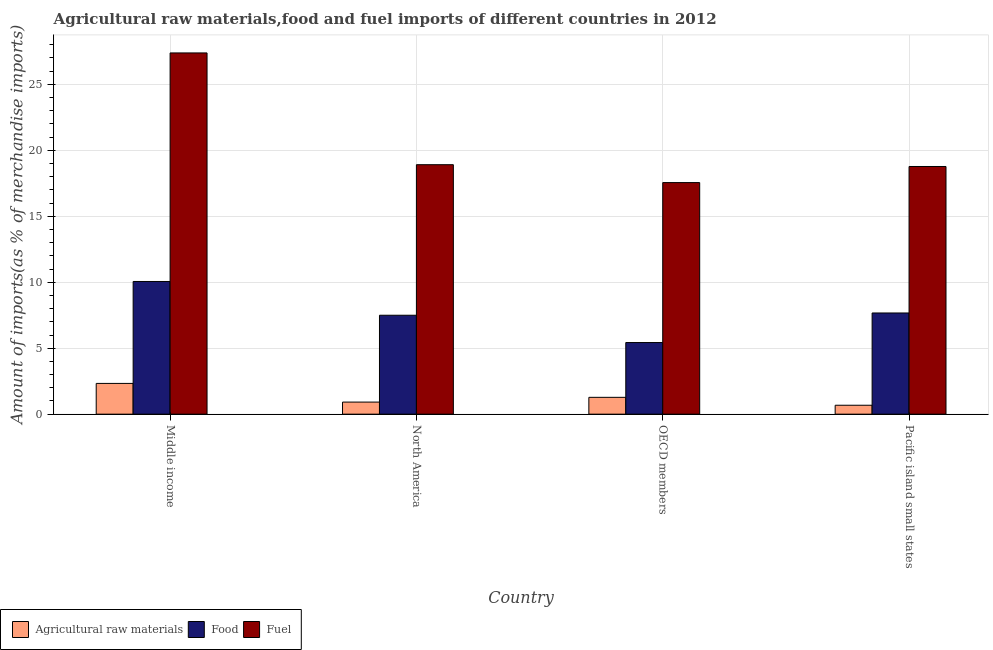How many different coloured bars are there?
Provide a short and direct response. 3. How many groups of bars are there?
Offer a terse response. 4. Are the number of bars per tick equal to the number of legend labels?
Your answer should be compact. Yes. How many bars are there on the 2nd tick from the left?
Offer a very short reply. 3. How many bars are there on the 2nd tick from the right?
Make the answer very short. 3. What is the label of the 4th group of bars from the left?
Your answer should be compact. Pacific island small states. In how many cases, is the number of bars for a given country not equal to the number of legend labels?
Ensure brevity in your answer.  0. What is the percentage of raw materials imports in Pacific island small states?
Ensure brevity in your answer.  0.68. Across all countries, what is the maximum percentage of fuel imports?
Your answer should be very brief. 27.38. Across all countries, what is the minimum percentage of food imports?
Your response must be concise. 5.43. In which country was the percentage of fuel imports minimum?
Your answer should be compact. OECD members. What is the total percentage of raw materials imports in the graph?
Provide a short and direct response. 5.2. What is the difference between the percentage of food imports in Middle income and that in North America?
Make the answer very short. 2.56. What is the difference between the percentage of raw materials imports in OECD members and the percentage of fuel imports in North America?
Your answer should be compact. -17.63. What is the average percentage of food imports per country?
Keep it short and to the point. 7.66. What is the difference between the percentage of raw materials imports and percentage of food imports in Middle income?
Your answer should be very brief. -7.73. What is the ratio of the percentage of fuel imports in North America to that in OECD members?
Give a very brief answer. 1.08. What is the difference between the highest and the second highest percentage of food imports?
Give a very brief answer. 2.39. What is the difference between the highest and the lowest percentage of fuel imports?
Offer a terse response. 9.83. In how many countries, is the percentage of food imports greater than the average percentage of food imports taken over all countries?
Keep it short and to the point. 2. What does the 2nd bar from the left in Pacific island small states represents?
Provide a succinct answer. Food. What does the 1st bar from the right in North America represents?
Provide a short and direct response. Fuel. Is it the case that in every country, the sum of the percentage of raw materials imports and percentage of food imports is greater than the percentage of fuel imports?
Give a very brief answer. No. How many countries are there in the graph?
Provide a short and direct response. 4. What is the difference between two consecutive major ticks on the Y-axis?
Offer a terse response. 5. Does the graph contain any zero values?
Provide a succinct answer. No. Where does the legend appear in the graph?
Offer a terse response. Bottom left. How many legend labels are there?
Your answer should be compact. 3. How are the legend labels stacked?
Provide a succinct answer. Horizontal. What is the title of the graph?
Ensure brevity in your answer.  Agricultural raw materials,food and fuel imports of different countries in 2012. Does "Ages 20-50" appear as one of the legend labels in the graph?
Offer a terse response. No. What is the label or title of the Y-axis?
Make the answer very short. Amount of imports(as % of merchandise imports). What is the Amount of imports(as % of merchandise imports) of Agricultural raw materials in Middle income?
Provide a short and direct response. 2.33. What is the Amount of imports(as % of merchandise imports) in Food in Middle income?
Keep it short and to the point. 10.06. What is the Amount of imports(as % of merchandise imports) in Fuel in Middle income?
Your answer should be compact. 27.38. What is the Amount of imports(as % of merchandise imports) in Agricultural raw materials in North America?
Offer a terse response. 0.92. What is the Amount of imports(as % of merchandise imports) in Food in North America?
Offer a terse response. 7.5. What is the Amount of imports(as % of merchandise imports) in Fuel in North America?
Offer a very short reply. 18.91. What is the Amount of imports(as % of merchandise imports) in Agricultural raw materials in OECD members?
Offer a terse response. 1.28. What is the Amount of imports(as % of merchandise imports) of Food in OECD members?
Give a very brief answer. 5.43. What is the Amount of imports(as % of merchandise imports) in Fuel in OECD members?
Offer a very short reply. 17.55. What is the Amount of imports(as % of merchandise imports) of Agricultural raw materials in Pacific island small states?
Provide a short and direct response. 0.68. What is the Amount of imports(as % of merchandise imports) of Food in Pacific island small states?
Give a very brief answer. 7.67. What is the Amount of imports(as % of merchandise imports) in Fuel in Pacific island small states?
Ensure brevity in your answer.  18.77. Across all countries, what is the maximum Amount of imports(as % of merchandise imports) in Agricultural raw materials?
Provide a succinct answer. 2.33. Across all countries, what is the maximum Amount of imports(as % of merchandise imports) of Food?
Your answer should be compact. 10.06. Across all countries, what is the maximum Amount of imports(as % of merchandise imports) of Fuel?
Offer a terse response. 27.38. Across all countries, what is the minimum Amount of imports(as % of merchandise imports) of Agricultural raw materials?
Your response must be concise. 0.68. Across all countries, what is the minimum Amount of imports(as % of merchandise imports) in Food?
Keep it short and to the point. 5.43. Across all countries, what is the minimum Amount of imports(as % of merchandise imports) in Fuel?
Ensure brevity in your answer.  17.55. What is the total Amount of imports(as % of merchandise imports) of Agricultural raw materials in the graph?
Give a very brief answer. 5.2. What is the total Amount of imports(as % of merchandise imports) in Food in the graph?
Provide a succinct answer. 30.65. What is the total Amount of imports(as % of merchandise imports) of Fuel in the graph?
Your answer should be very brief. 82.61. What is the difference between the Amount of imports(as % of merchandise imports) in Agricultural raw materials in Middle income and that in North America?
Ensure brevity in your answer.  1.42. What is the difference between the Amount of imports(as % of merchandise imports) of Food in Middle income and that in North America?
Your answer should be very brief. 2.56. What is the difference between the Amount of imports(as % of merchandise imports) in Fuel in Middle income and that in North America?
Make the answer very short. 8.47. What is the difference between the Amount of imports(as % of merchandise imports) in Agricultural raw materials in Middle income and that in OECD members?
Offer a very short reply. 1.05. What is the difference between the Amount of imports(as % of merchandise imports) in Food in Middle income and that in OECD members?
Make the answer very short. 4.63. What is the difference between the Amount of imports(as % of merchandise imports) of Fuel in Middle income and that in OECD members?
Provide a succinct answer. 9.83. What is the difference between the Amount of imports(as % of merchandise imports) of Agricultural raw materials in Middle income and that in Pacific island small states?
Provide a short and direct response. 1.65. What is the difference between the Amount of imports(as % of merchandise imports) of Food in Middle income and that in Pacific island small states?
Make the answer very short. 2.39. What is the difference between the Amount of imports(as % of merchandise imports) of Fuel in Middle income and that in Pacific island small states?
Keep it short and to the point. 8.61. What is the difference between the Amount of imports(as % of merchandise imports) in Agricultural raw materials in North America and that in OECD members?
Keep it short and to the point. -0.36. What is the difference between the Amount of imports(as % of merchandise imports) of Food in North America and that in OECD members?
Provide a succinct answer. 2.07. What is the difference between the Amount of imports(as % of merchandise imports) in Fuel in North America and that in OECD members?
Your answer should be very brief. 1.36. What is the difference between the Amount of imports(as % of merchandise imports) of Agricultural raw materials in North America and that in Pacific island small states?
Give a very brief answer. 0.24. What is the difference between the Amount of imports(as % of merchandise imports) in Food in North America and that in Pacific island small states?
Provide a short and direct response. -0.17. What is the difference between the Amount of imports(as % of merchandise imports) of Fuel in North America and that in Pacific island small states?
Your answer should be very brief. 0.14. What is the difference between the Amount of imports(as % of merchandise imports) of Agricultural raw materials in OECD members and that in Pacific island small states?
Provide a short and direct response. 0.6. What is the difference between the Amount of imports(as % of merchandise imports) in Food in OECD members and that in Pacific island small states?
Make the answer very short. -2.24. What is the difference between the Amount of imports(as % of merchandise imports) of Fuel in OECD members and that in Pacific island small states?
Offer a terse response. -1.22. What is the difference between the Amount of imports(as % of merchandise imports) in Agricultural raw materials in Middle income and the Amount of imports(as % of merchandise imports) in Food in North America?
Your answer should be very brief. -5.17. What is the difference between the Amount of imports(as % of merchandise imports) in Agricultural raw materials in Middle income and the Amount of imports(as % of merchandise imports) in Fuel in North America?
Keep it short and to the point. -16.58. What is the difference between the Amount of imports(as % of merchandise imports) in Food in Middle income and the Amount of imports(as % of merchandise imports) in Fuel in North America?
Your answer should be very brief. -8.85. What is the difference between the Amount of imports(as % of merchandise imports) in Agricultural raw materials in Middle income and the Amount of imports(as % of merchandise imports) in Food in OECD members?
Offer a terse response. -3.1. What is the difference between the Amount of imports(as % of merchandise imports) in Agricultural raw materials in Middle income and the Amount of imports(as % of merchandise imports) in Fuel in OECD members?
Provide a succinct answer. -15.22. What is the difference between the Amount of imports(as % of merchandise imports) in Food in Middle income and the Amount of imports(as % of merchandise imports) in Fuel in OECD members?
Give a very brief answer. -7.5. What is the difference between the Amount of imports(as % of merchandise imports) in Agricultural raw materials in Middle income and the Amount of imports(as % of merchandise imports) in Food in Pacific island small states?
Offer a terse response. -5.34. What is the difference between the Amount of imports(as % of merchandise imports) of Agricultural raw materials in Middle income and the Amount of imports(as % of merchandise imports) of Fuel in Pacific island small states?
Your answer should be very brief. -16.44. What is the difference between the Amount of imports(as % of merchandise imports) of Food in Middle income and the Amount of imports(as % of merchandise imports) of Fuel in Pacific island small states?
Offer a terse response. -8.72. What is the difference between the Amount of imports(as % of merchandise imports) of Agricultural raw materials in North America and the Amount of imports(as % of merchandise imports) of Food in OECD members?
Your answer should be compact. -4.51. What is the difference between the Amount of imports(as % of merchandise imports) of Agricultural raw materials in North America and the Amount of imports(as % of merchandise imports) of Fuel in OECD members?
Give a very brief answer. -16.64. What is the difference between the Amount of imports(as % of merchandise imports) of Food in North America and the Amount of imports(as % of merchandise imports) of Fuel in OECD members?
Offer a terse response. -10.05. What is the difference between the Amount of imports(as % of merchandise imports) of Agricultural raw materials in North America and the Amount of imports(as % of merchandise imports) of Food in Pacific island small states?
Provide a succinct answer. -6.75. What is the difference between the Amount of imports(as % of merchandise imports) of Agricultural raw materials in North America and the Amount of imports(as % of merchandise imports) of Fuel in Pacific island small states?
Make the answer very short. -17.86. What is the difference between the Amount of imports(as % of merchandise imports) in Food in North America and the Amount of imports(as % of merchandise imports) in Fuel in Pacific island small states?
Your response must be concise. -11.27. What is the difference between the Amount of imports(as % of merchandise imports) of Agricultural raw materials in OECD members and the Amount of imports(as % of merchandise imports) of Food in Pacific island small states?
Offer a very short reply. -6.39. What is the difference between the Amount of imports(as % of merchandise imports) in Agricultural raw materials in OECD members and the Amount of imports(as % of merchandise imports) in Fuel in Pacific island small states?
Make the answer very short. -17.5. What is the difference between the Amount of imports(as % of merchandise imports) of Food in OECD members and the Amount of imports(as % of merchandise imports) of Fuel in Pacific island small states?
Your response must be concise. -13.34. What is the average Amount of imports(as % of merchandise imports) in Agricultural raw materials per country?
Ensure brevity in your answer.  1.3. What is the average Amount of imports(as % of merchandise imports) in Food per country?
Make the answer very short. 7.66. What is the average Amount of imports(as % of merchandise imports) of Fuel per country?
Make the answer very short. 20.65. What is the difference between the Amount of imports(as % of merchandise imports) in Agricultural raw materials and Amount of imports(as % of merchandise imports) in Food in Middle income?
Make the answer very short. -7.73. What is the difference between the Amount of imports(as % of merchandise imports) in Agricultural raw materials and Amount of imports(as % of merchandise imports) in Fuel in Middle income?
Provide a short and direct response. -25.05. What is the difference between the Amount of imports(as % of merchandise imports) in Food and Amount of imports(as % of merchandise imports) in Fuel in Middle income?
Your answer should be very brief. -17.32. What is the difference between the Amount of imports(as % of merchandise imports) of Agricultural raw materials and Amount of imports(as % of merchandise imports) of Food in North America?
Provide a succinct answer. -6.58. What is the difference between the Amount of imports(as % of merchandise imports) in Agricultural raw materials and Amount of imports(as % of merchandise imports) in Fuel in North America?
Your answer should be very brief. -17.99. What is the difference between the Amount of imports(as % of merchandise imports) of Food and Amount of imports(as % of merchandise imports) of Fuel in North America?
Your response must be concise. -11.41. What is the difference between the Amount of imports(as % of merchandise imports) of Agricultural raw materials and Amount of imports(as % of merchandise imports) of Food in OECD members?
Offer a very short reply. -4.15. What is the difference between the Amount of imports(as % of merchandise imports) of Agricultural raw materials and Amount of imports(as % of merchandise imports) of Fuel in OECD members?
Your response must be concise. -16.28. What is the difference between the Amount of imports(as % of merchandise imports) in Food and Amount of imports(as % of merchandise imports) in Fuel in OECD members?
Keep it short and to the point. -12.12. What is the difference between the Amount of imports(as % of merchandise imports) of Agricultural raw materials and Amount of imports(as % of merchandise imports) of Food in Pacific island small states?
Keep it short and to the point. -6.99. What is the difference between the Amount of imports(as % of merchandise imports) of Agricultural raw materials and Amount of imports(as % of merchandise imports) of Fuel in Pacific island small states?
Offer a very short reply. -18.1. What is the difference between the Amount of imports(as % of merchandise imports) in Food and Amount of imports(as % of merchandise imports) in Fuel in Pacific island small states?
Your answer should be compact. -11.1. What is the ratio of the Amount of imports(as % of merchandise imports) of Agricultural raw materials in Middle income to that in North America?
Provide a short and direct response. 2.55. What is the ratio of the Amount of imports(as % of merchandise imports) in Food in Middle income to that in North America?
Make the answer very short. 1.34. What is the ratio of the Amount of imports(as % of merchandise imports) in Fuel in Middle income to that in North America?
Your answer should be very brief. 1.45. What is the ratio of the Amount of imports(as % of merchandise imports) of Agricultural raw materials in Middle income to that in OECD members?
Your response must be concise. 1.83. What is the ratio of the Amount of imports(as % of merchandise imports) in Food in Middle income to that in OECD members?
Your response must be concise. 1.85. What is the ratio of the Amount of imports(as % of merchandise imports) of Fuel in Middle income to that in OECD members?
Give a very brief answer. 1.56. What is the ratio of the Amount of imports(as % of merchandise imports) of Agricultural raw materials in Middle income to that in Pacific island small states?
Provide a succinct answer. 3.45. What is the ratio of the Amount of imports(as % of merchandise imports) in Food in Middle income to that in Pacific island small states?
Your response must be concise. 1.31. What is the ratio of the Amount of imports(as % of merchandise imports) of Fuel in Middle income to that in Pacific island small states?
Give a very brief answer. 1.46. What is the ratio of the Amount of imports(as % of merchandise imports) of Agricultural raw materials in North America to that in OECD members?
Give a very brief answer. 0.72. What is the ratio of the Amount of imports(as % of merchandise imports) in Food in North America to that in OECD members?
Provide a short and direct response. 1.38. What is the ratio of the Amount of imports(as % of merchandise imports) in Fuel in North America to that in OECD members?
Make the answer very short. 1.08. What is the ratio of the Amount of imports(as % of merchandise imports) in Agricultural raw materials in North America to that in Pacific island small states?
Offer a terse response. 1.35. What is the ratio of the Amount of imports(as % of merchandise imports) in Food in North America to that in Pacific island small states?
Offer a terse response. 0.98. What is the ratio of the Amount of imports(as % of merchandise imports) of Fuel in North America to that in Pacific island small states?
Provide a short and direct response. 1.01. What is the ratio of the Amount of imports(as % of merchandise imports) of Agricultural raw materials in OECD members to that in Pacific island small states?
Make the answer very short. 1.89. What is the ratio of the Amount of imports(as % of merchandise imports) of Food in OECD members to that in Pacific island small states?
Your answer should be very brief. 0.71. What is the ratio of the Amount of imports(as % of merchandise imports) in Fuel in OECD members to that in Pacific island small states?
Your answer should be very brief. 0.94. What is the difference between the highest and the second highest Amount of imports(as % of merchandise imports) of Agricultural raw materials?
Make the answer very short. 1.05. What is the difference between the highest and the second highest Amount of imports(as % of merchandise imports) of Food?
Keep it short and to the point. 2.39. What is the difference between the highest and the second highest Amount of imports(as % of merchandise imports) in Fuel?
Your answer should be very brief. 8.47. What is the difference between the highest and the lowest Amount of imports(as % of merchandise imports) in Agricultural raw materials?
Your answer should be compact. 1.65. What is the difference between the highest and the lowest Amount of imports(as % of merchandise imports) in Food?
Ensure brevity in your answer.  4.63. What is the difference between the highest and the lowest Amount of imports(as % of merchandise imports) of Fuel?
Your response must be concise. 9.83. 